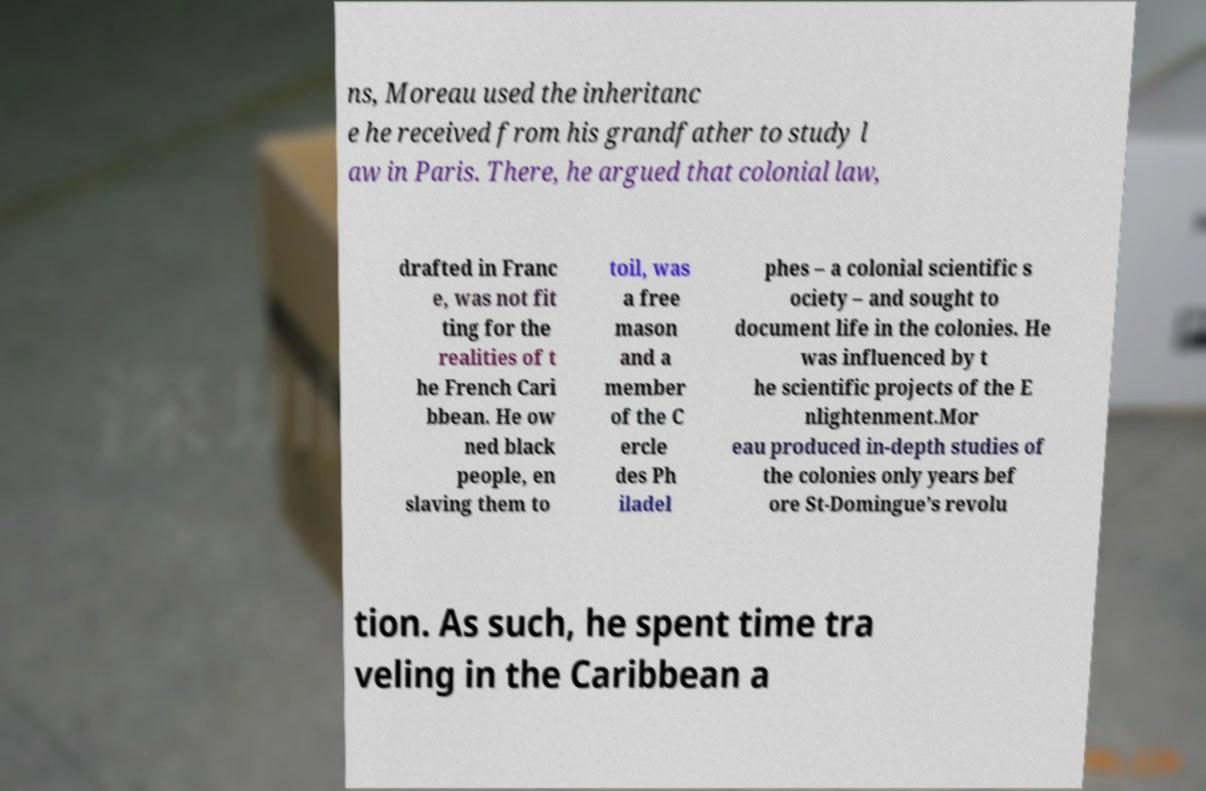Could you assist in decoding the text presented in this image and type it out clearly? ns, Moreau used the inheritanc e he received from his grandfather to study l aw in Paris. There, he argued that colonial law, drafted in Franc e, was not fit ting for the realities of t he French Cari bbean. He ow ned black people, en slaving them to toil, was a free mason and a member of the C ercle des Ph iladel phes – a colonial scientific s ociety – and sought to document life in the colonies. He was influenced by t he scientific projects of the E nlightenment.Mor eau produced in-depth studies of the colonies only years bef ore St-Domingue’s revolu tion. As such, he spent time tra veling in the Caribbean a 